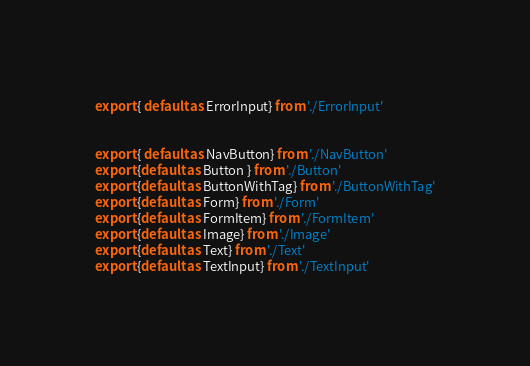<code> <loc_0><loc_0><loc_500><loc_500><_JavaScript_>export { default as ErrorInput} from './ErrorInput'


export { default as NavButton} from './NavButton'
export {default as Button } from './Button'
export {default as ButtonWithTag} from './ButtonWithTag'
export {default as Form} from './Form'
export {default as FormItem} from './FormItem'
export {default as Image} from './Image'
export {default as Text} from './Text'
export {default as TextInput} from './TextInput'
</code> 